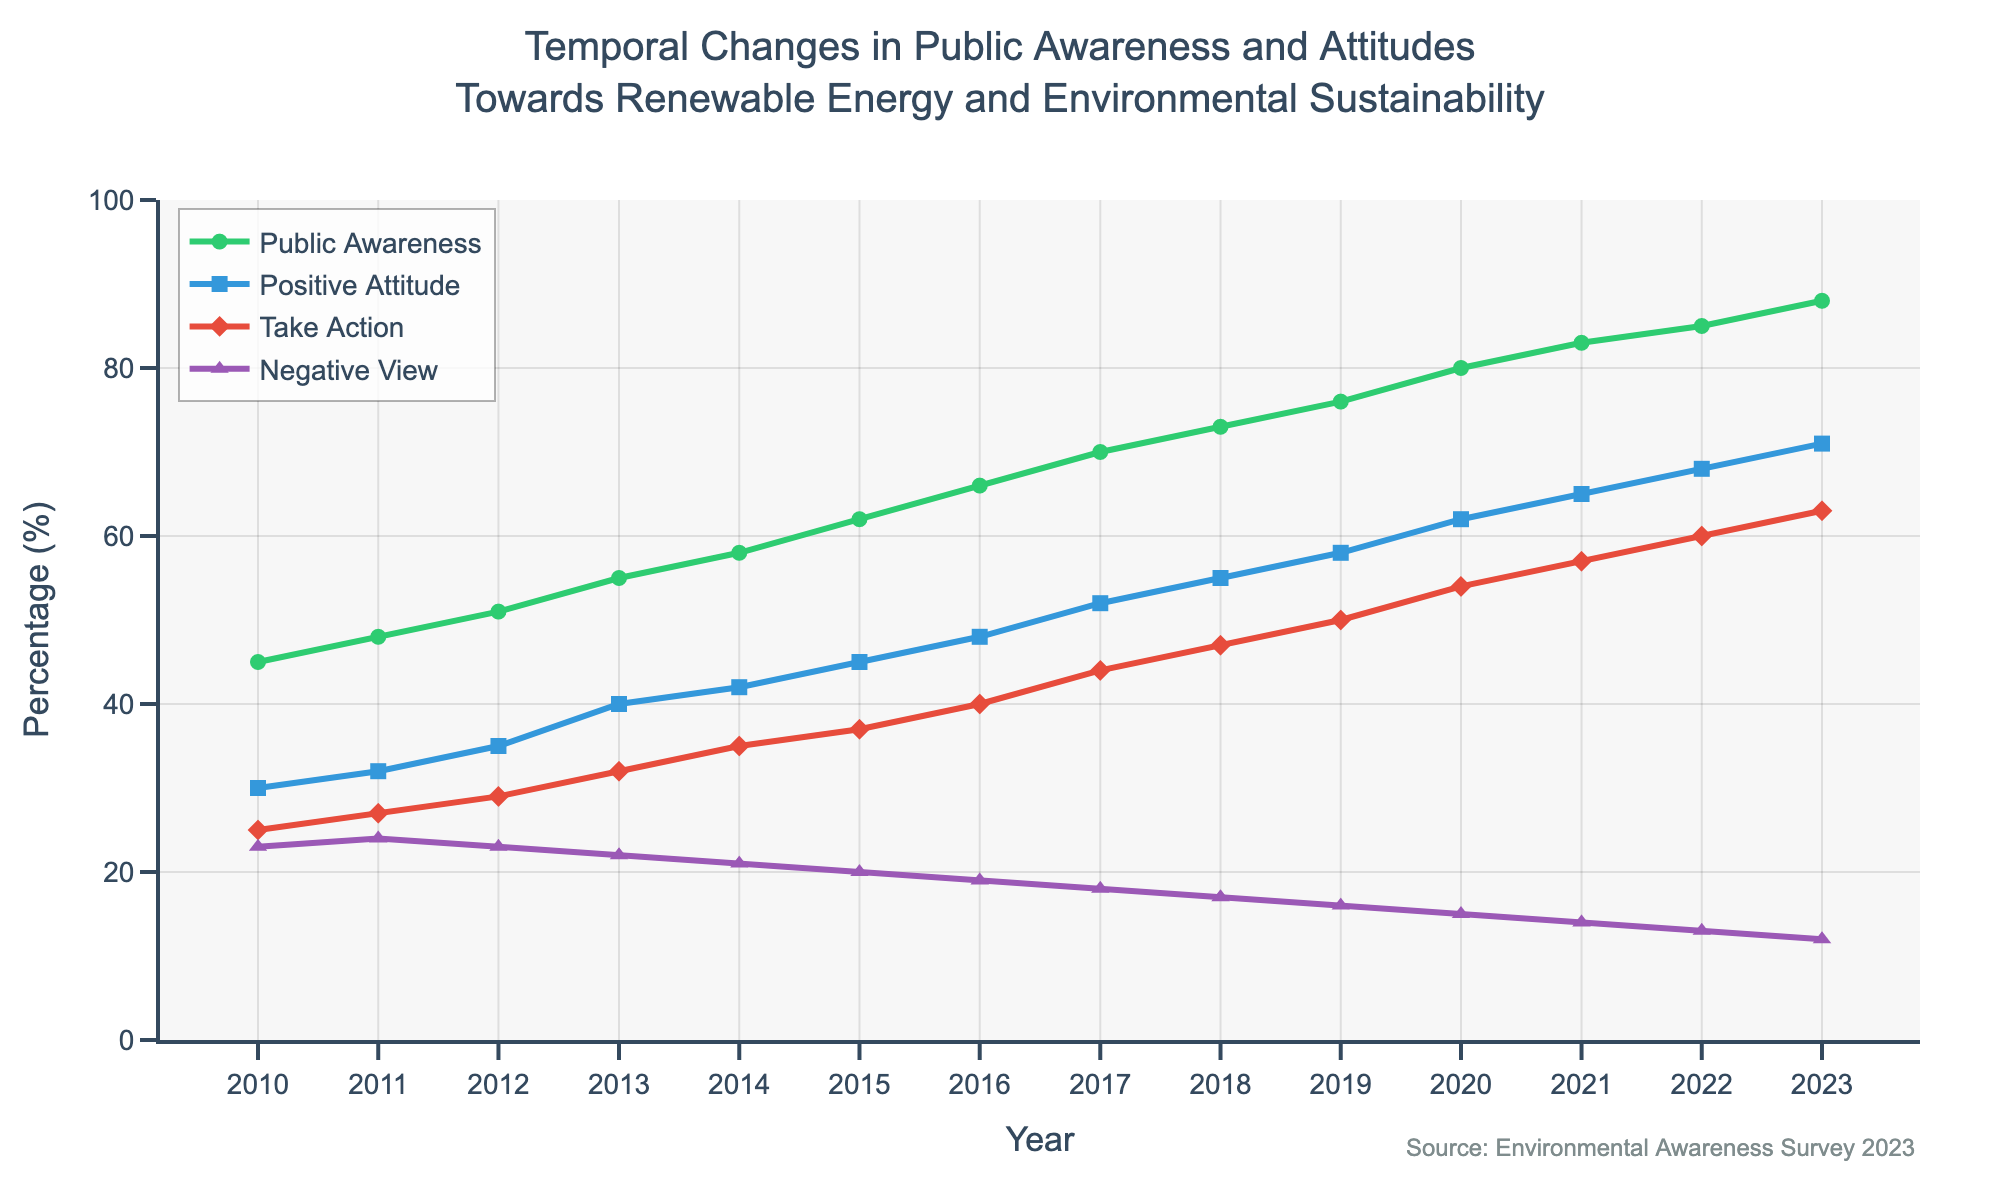What are the different lines or metrics displayed in the plot? There are four lines representing different metrics: Public Awareness, Positive Attitude, Take Action, and Negative View, as indicated by the legend in the plot.
Answer: Public Awareness, Positive Attitude, Take Action, Negative View What is the title of the plot? The title of the plot is located at the top of the figure and reads: "Temporal Changes in Public Awareness and Attitudes Towards Renewable Energy and Environmental Sustainability".
Answer: Temporal Changes in Public Awareness and Attitudes Towards Renewable Energy and Environmental Sustainability By how much did public awareness increase from 2010 to 2023? To find the increase in public awareness from 2010 to 2023, subtract the 2010 value from the 2023 value. For public awareness, this would be 88 - 45.
Answer: 43% Which metric shows the highest value in 2023? To find the highest value in 2023, we look at the metrics at the end of the plot and compare their values. In 2023, Public Awareness has the highest value of 88%.
Answer: Public Awareness What is the overall trend in positive attitude from 2010 to 2023? To determine the overall trend, observe the direction and pattern of the line for Positive Attitude from the beginning to the end of the timeline. The positive attitude line shows a consistent upward trend.
Answer: Increasing How does the trend in Negative View compare to the other metrics over the same period? The Negative View line shows a downward trend, while the other metrics (Public Awareness, Positive Attitude, and Take Action) show an upward trend over the same period.
Answer: Downward, while others are upward What was the percentage of people who take action in 2016 compared to 2020? Find the values of the "Take Action" metric in 2016 and 2020 by looking at the data points on the plot. In 2016 it was 40%, and in 2020 it was 54%.
Answer: 40% in 2016, 54% in 2020 Which year had the smallest increase in public awareness compared to the previous year? To find the smallest increase, calculate the year-on-year changes and identify the smallest one. The smallest increase is from 2022 (85%) to 2023 (88%), which is an increase of 3%.
Answer: 2023 compared to 2022 If the trend continues, what might we expect for the public awareness percentage in 2025? Assuming the trend continues, we can estimate future values by observing the average yearly increase. The average increase over the years is roughly 3-4%, so we might expect public awareness to be around 92-96% by 2025.
Answer: 92-96% What is the difference between the percentage of positive attitude and negative view in 2023? Subtract the negative view percentage from the positive attitude percentage for the year 2023. The positive attitude is 71%, and the negative view is 12%, so the difference is 71 - 12.
Answer: 59% 